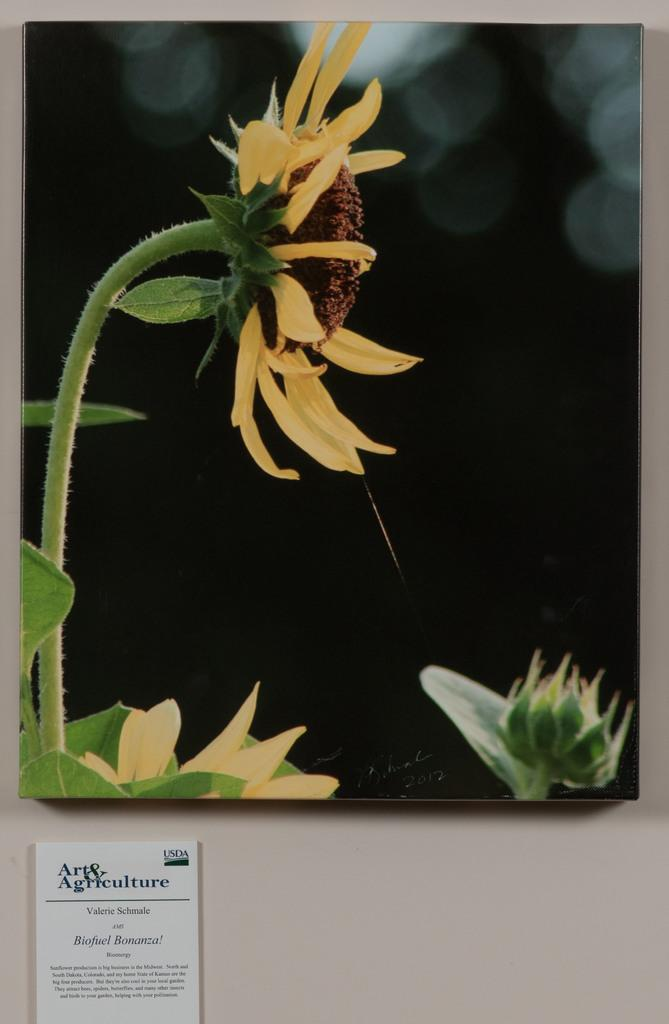What is on the card that is visible in the image? The card has a sunflower picture on it. Where is the card located in the image? The card is pasted on the wall. What type of watch is the man wearing in the image? There is no man or watch present in the image; it only features a card with a sunflower picture on it. 